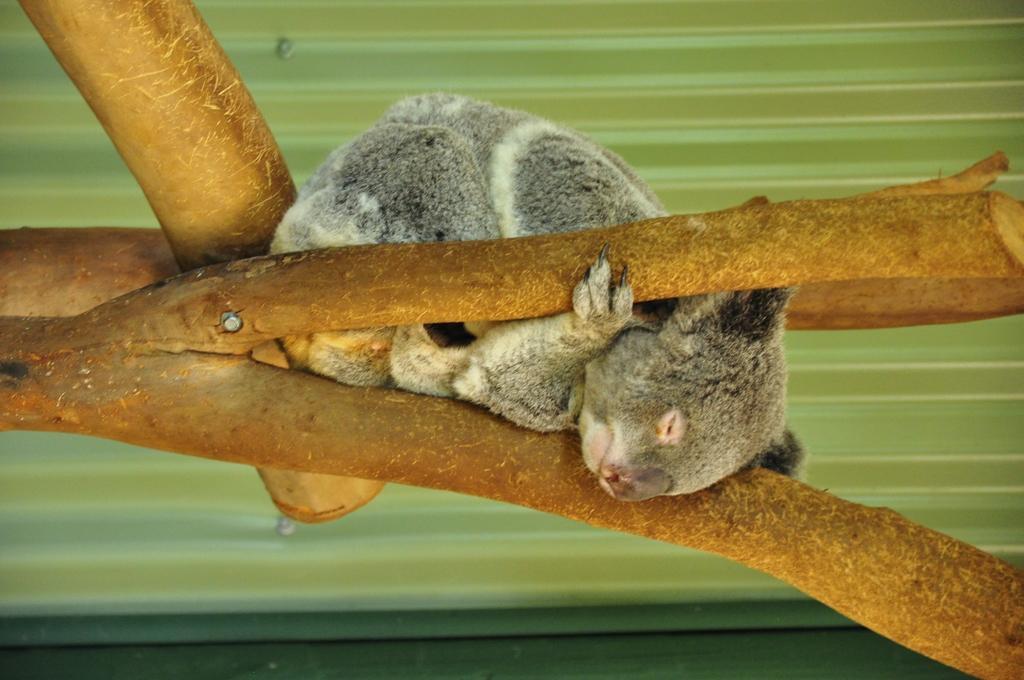Could you give a brief overview of what you see in this image? In this image there is an animal on a branch, in the background it is in green color. 